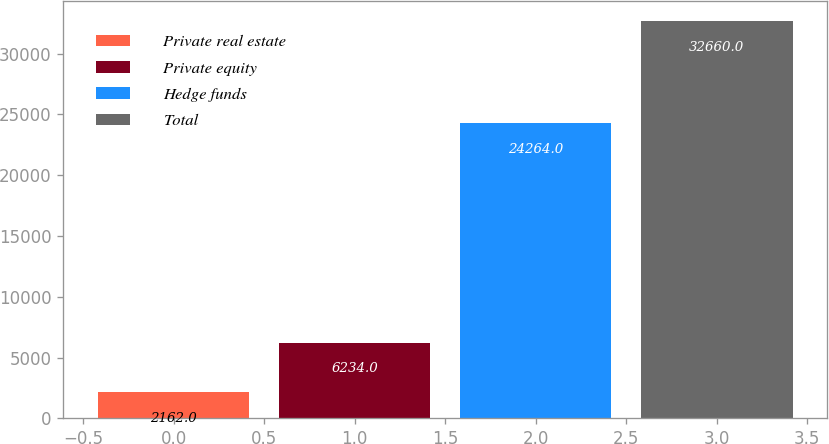Convert chart to OTSL. <chart><loc_0><loc_0><loc_500><loc_500><bar_chart><fcel>Private real estate<fcel>Private equity<fcel>Hedge funds<fcel>Total<nl><fcel>2162<fcel>6234<fcel>24264<fcel>32660<nl></chart> 